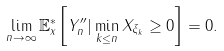<formula> <loc_0><loc_0><loc_500><loc_500>\lim _ { n \to \infty } \mathbb { E } _ { x } ^ { * } \left [ Y _ { n } ^ { \prime \prime } | \min _ { k \leq n } X _ { \xi _ { k } } \geq 0 \right ] = 0 .</formula> 